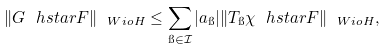Convert formula to latex. <formula><loc_0><loc_0><loc_500><loc_500>\| G \ h s t a r F \| _ { \ W i o H } \leq \sum _ { \i \in \mathcal { I } } | a _ { \i } | \| T _ { \i } \chi \ h s t a r F \| _ { \ W i o H } ,</formula> 